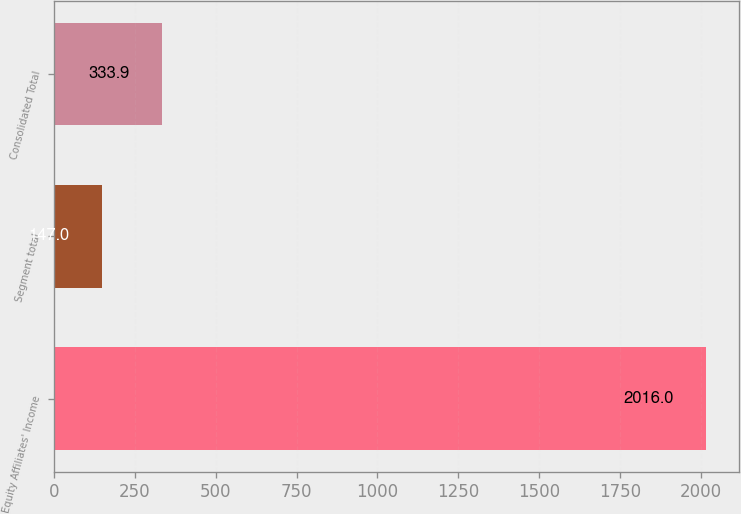Convert chart. <chart><loc_0><loc_0><loc_500><loc_500><bar_chart><fcel>Equity Affiliates' Income<fcel>Segment total<fcel>Consolidated Total<nl><fcel>2016<fcel>147<fcel>333.9<nl></chart> 